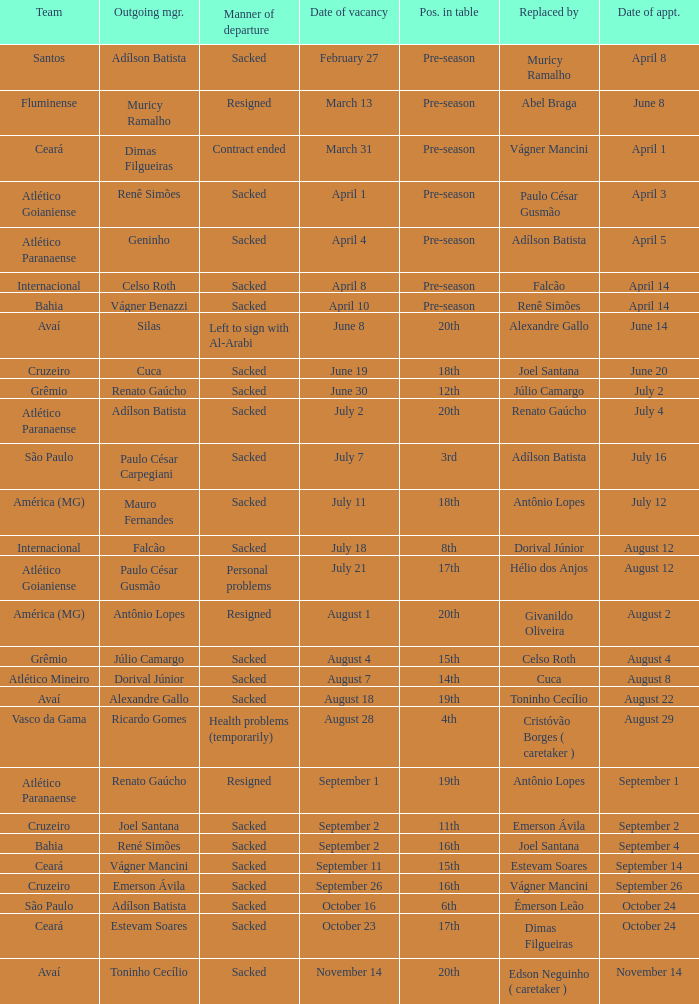Why did Geninho leave as manager? Sacked. Can you parse all the data within this table? {'header': ['Team', 'Outgoing mgr.', 'Manner of departure', 'Date of vacancy', 'Pos. in table', 'Replaced by', 'Date of appt.'], 'rows': [['Santos', 'Adílson Batista', 'Sacked', 'February 27', 'Pre-season', 'Muricy Ramalho', 'April 8'], ['Fluminense', 'Muricy Ramalho', 'Resigned', 'March 13', 'Pre-season', 'Abel Braga', 'June 8'], ['Ceará', 'Dimas Filgueiras', 'Contract ended', 'March 31', 'Pre-season', 'Vágner Mancini', 'April 1'], ['Atlético Goianiense', 'Renê Simões', 'Sacked', 'April 1', 'Pre-season', 'Paulo César Gusmão', 'April 3'], ['Atlético Paranaense', 'Geninho', 'Sacked', 'April 4', 'Pre-season', 'Adílson Batista', 'April 5'], ['Internacional', 'Celso Roth', 'Sacked', 'April 8', 'Pre-season', 'Falcão', 'April 14'], ['Bahia', 'Vágner Benazzi', 'Sacked', 'April 10', 'Pre-season', 'Renê Simões', 'April 14'], ['Avaí', 'Silas', 'Left to sign with Al-Arabi', 'June 8', '20th', 'Alexandre Gallo', 'June 14'], ['Cruzeiro', 'Cuca', 'Sacked', 'June 19', '18th', 'Joel Santana', 'June 20'], ['Grêmio', 'Renato Gaúcho', 'Sacked', 'June 30', '12th', 'Júlio Camargo', 'July 2'], ['Atlético Paranaense', 'Adílson Batista', 'Sacked', 'July 2', '20th', 'Renato Gaúcho', 'July 4'], ['São Paulo', 'Paulo César Carpegiani', 'Sacked', 'July 7', '3rd', 'Adílson Batista', 'July 16'], ['América (MG)', 'Mauro Fernandes', 'Sacked', 'July 11', '18th', 'Antônio Lopes', 'July 12'], ['Internacional', 'Falcão', 'Sacked', 'July 18', '8th', 'Dorival Júnior', 'August 12'], ['Atlético Goianiense', 'Paulo César Gusmão', 'Personal problems', 'July 21', '17th', 'Hélio dos Anjos', 'August 12'], ['América (MG)', 'Antônio Lopes', 'Resigned', 'August 1', '20th', 'Givanildo Oliveira', 'August 2'], ['Grêmio', 'Júlio Camargo', 'Sacked', 'August 4', '15th', 'Celso Roth', 'August 4'], ['Atlético Mineiro', 'Dorival Júnior', 'Sacked', 'August 7', '14th', 'Cuca', 'August 8'], ['Avaí', 'Alexandre Gallo', 'Sacked', 'August 18', '19th', 'Toninho Cecílio', 'August 22'], ['Vasco da Gama', 'Ricardo Gomes', 'Health problems (temporarily)', 'August 28', '4th', 'Cristóvão Borges ( caretaker )', 'August 29'], ['Atlético Paranaense', 'Renato Gaúcho', 'Resigned', 'September 1', '19th', 'Antônio Lopes', 'September 1'], ['Cruzeiro', 'Joel Santana', 'Sacked', 'September 2', '11th', 'Emerson Ávila', 'September 2'], ['Bahia', 'René Simões', 'Sacked', 'September 2', '16th', 'Joel Santana', 'September 4'], ['Ceará', 'Vágner Mancini', 'Sacked', 'September 11', '15th', 'Estevam Soares', 'September 14'], ['Cruzeiro', 'Emerson Ávila', 'Sacked', 'September 26', '16th', 'Vágner Mancini', 'September 26'], ['São Paulo', 'Adílson Batista', 'Sacked', 'October 16', '6th', 'Émerson Leão', 'October 24'], ['Ceará', 'Estevam Soares', 'Sacked', 'October 23', '17th', 'Dimas Filgueiras', 'October 24'], ['Avaí', 'Toninho Cecílio', 'Sacked', 'November 14', '20th', 'Edson Neguinho ( caretaker )', 'November 14']]} 